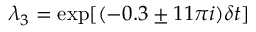<formula> <loc_0><loc_0><loc_500><loc_500>\lambda _ { 3 } = \exp [ ( - 0 . 3 \pm 1 1 \pi i ) \delta t ]</formula> 